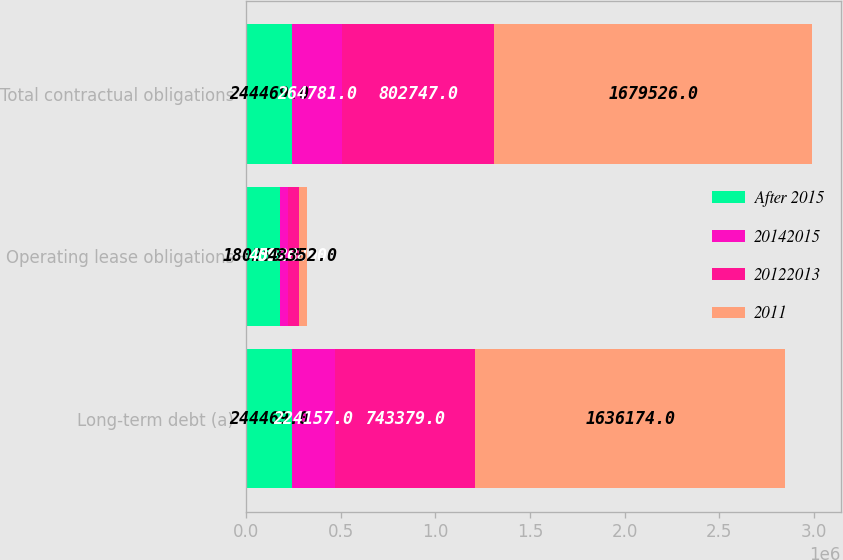<chart> <loc_0><loc_0><loc_500><loc_500><stacked_bar_chart><ecel><fcel>Long-term debt (a)<fcel>Operating lease obligations<fcel>Total contractual obligations<nl><fcel>After 2015<fcel>244469<fcel>180258<fcel>244469<nl><fcel>20142015<fcel>224157<fcel>40028<fcel>264781<nl><fcel>20122013<fcel>743379<fcel>59368<fcel>802747<nl><fcel>2011<fcel>1.63617e+06<fcel>43352<fcel>1.67953e+06<nl></chart> 